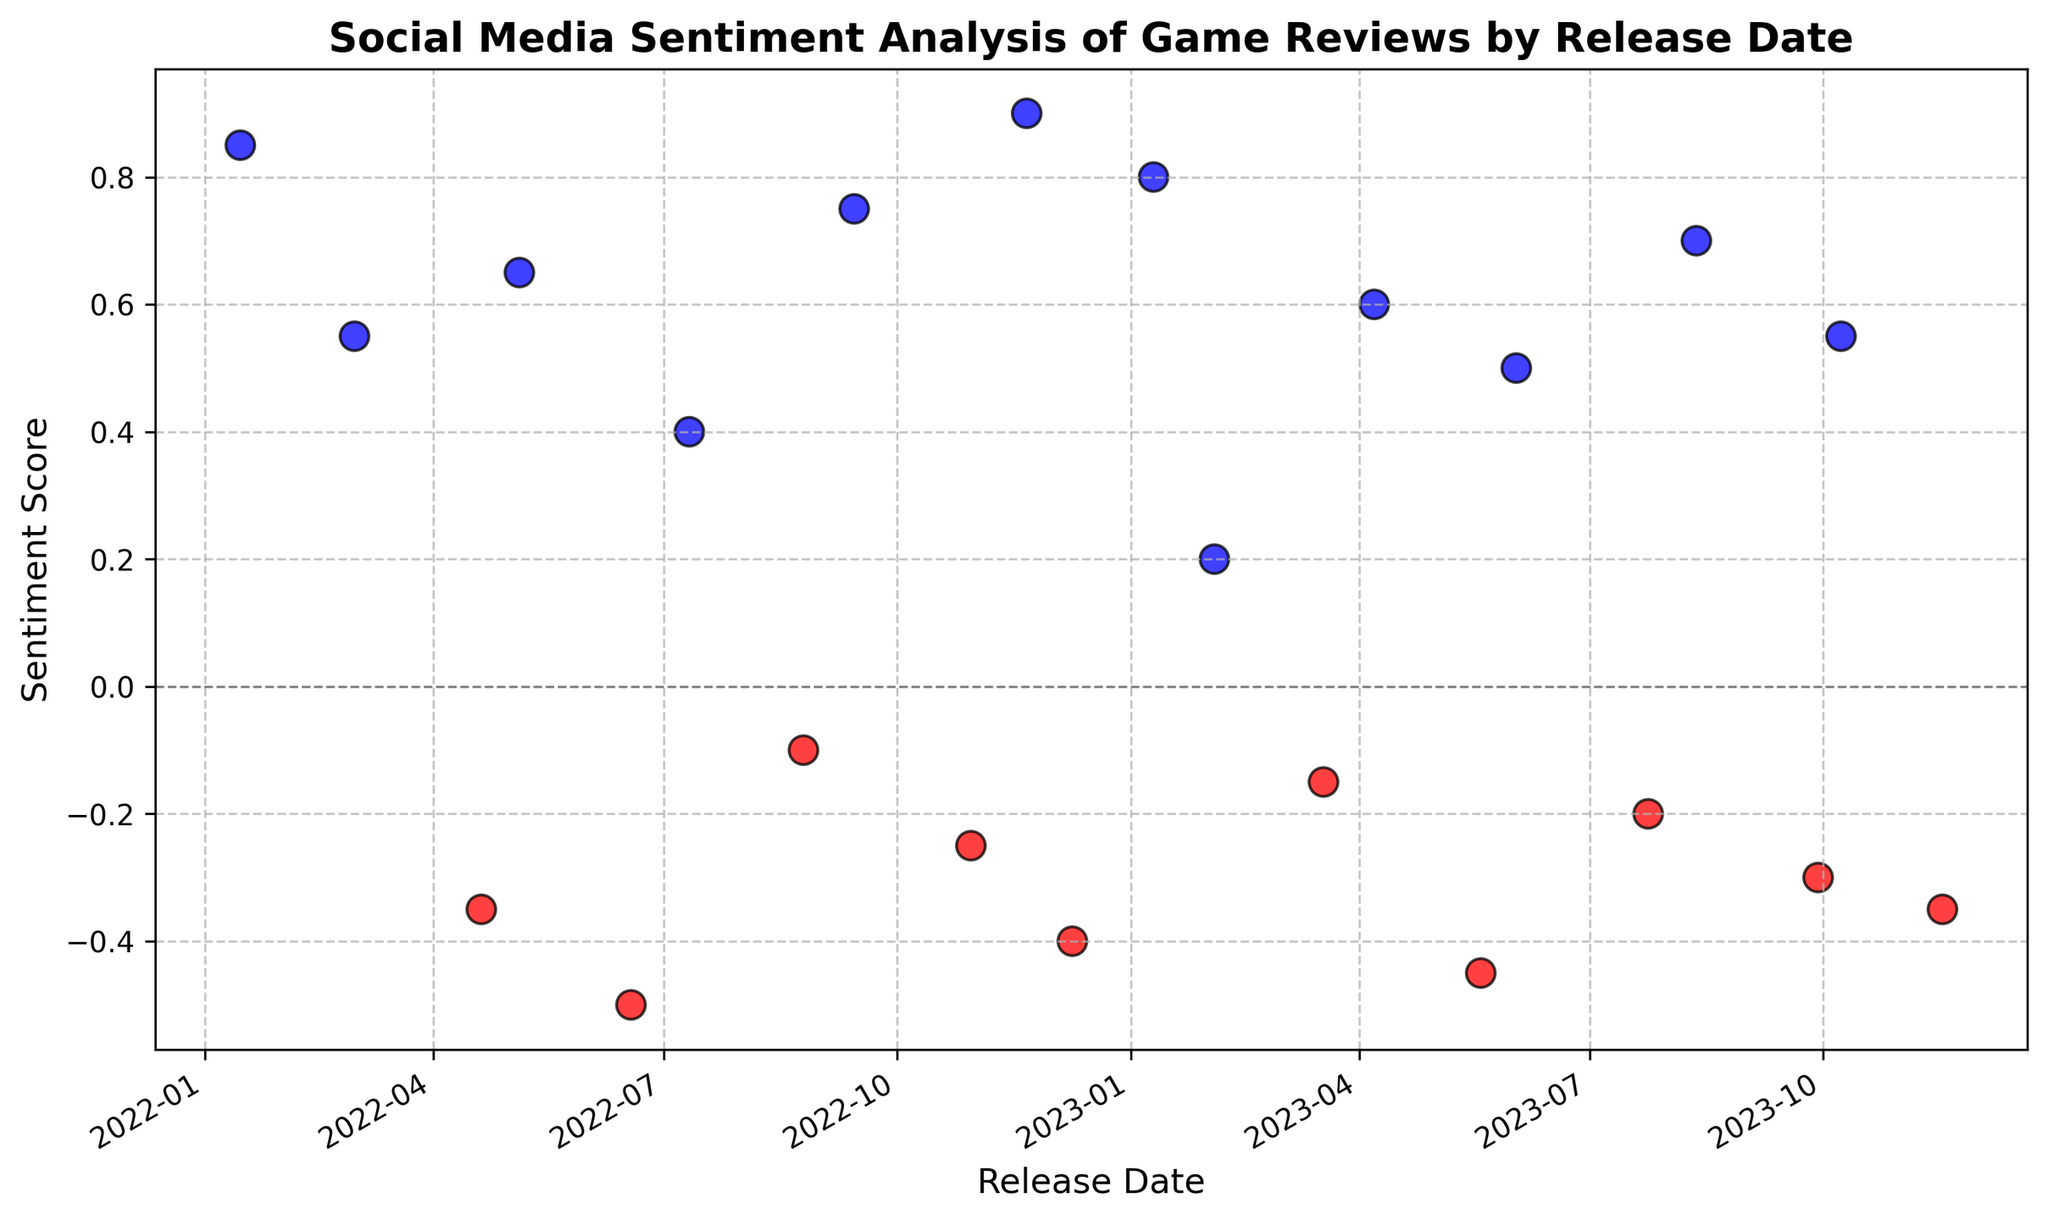What trends can be observed in the sentiment scores over time? Examine the pattern of the points on the scatter plot. The sentiment scores fluctuate between positive and negative values over time, but there's no clear increasing or decreasing trend as the points are fairly balanced on both sides of the zero line.
Answer: Fluctuating trend Which release date had the highest sentiment score? Locate the highest point on the vertical axis and check its corresponding date on the horizontal axis. The highest sentiment score is 0.90, which corresponds to the release date 2022-11-21.
Answer: 2022-11-21 Are there more positive or negative sentiment scores in 2023? Count the positive and negative sentiment scores for release dates in 2023. Positive sentiment scores are (0.80, 0.20, 0.60, 0.50, 0.70, 0.55). Negative sentiment scores are (-0.15, -0.45, -0.20, -0.30, -0.35). There are 6 positive and 5 negative scores.
Answer: More positive How many release dates have a sentiment score below -0.4? Identify the points below the -0.4 sentiment score and count them. The dates with sentiment scores below -0.4 are 2022-06-18, 2022-12-09, and 2023-05-19.
Answer: 3 What is the average sentiment score for the year 2022? Sum all the sentiment scores for 2022 and divide by the number of data points. Scores: (0.85, 0.55, -0.35, 0.65, -0.50, 0.40, -0.10, 0.75, -0.25, 0.90, -0.40). Total: (0.85 + 0.55 - 0.35 + 0.65 - 0.50 + 0.40 - 0.10 + 0.75 - 0.25 + 0.90 - 0.40) = 3.90. There are 11 data points, so 3.90 / 11 = 0.3545.
Answer: 0.35 When was the sentiment score the lowest? Locate the lowest point on the vertical axis and check its corresponding date on the horizontal axis. The lowest sentiment score is -0.50, which corresponds to the release date 2022-06-18.
Answer: 2022-06-18 